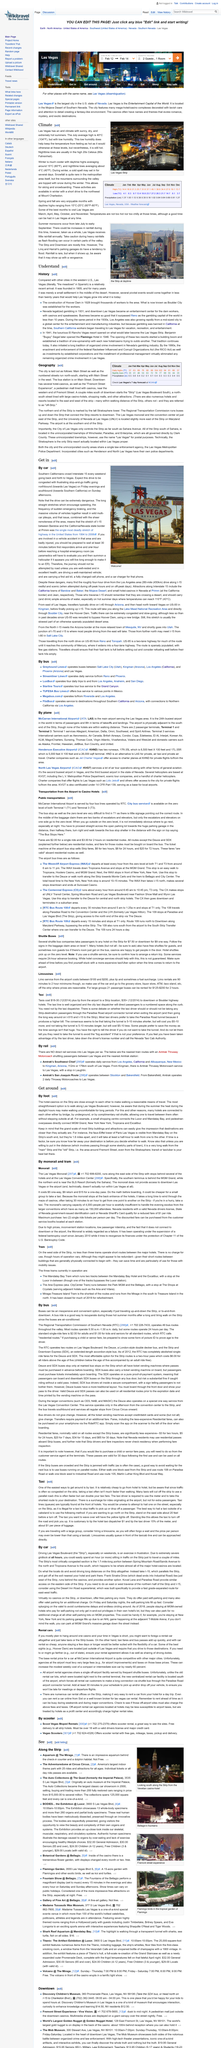Outline some significant characteristics in this image. In Las Vegas, the nighttime lows typically range in the high 20's degrees Celsius, commonly reaching this temperature range during the colder months of the year. During the month of November, the daily high temperature is 66° F and the nightly low temperature is 44° F. The MGM Grand, New York New York, Tropicana, and Excalibur are places that can be accessed by pedestrians without facing the issue of heat. You can check Las Vegas' 7-day forecast at the National Oceanic and Atmospheric Administration (NOAA). The Las Vegas Strip is officially named Las Vegas Boulevard. 